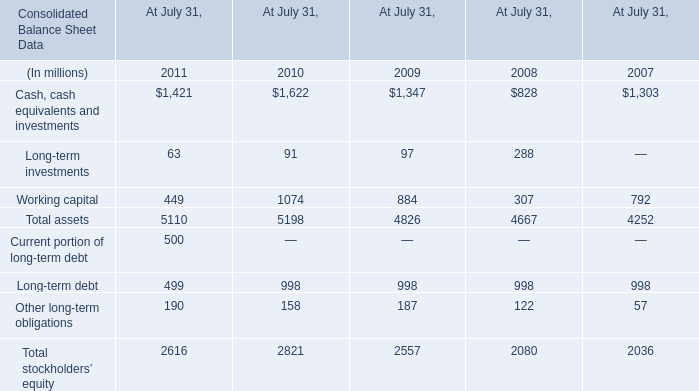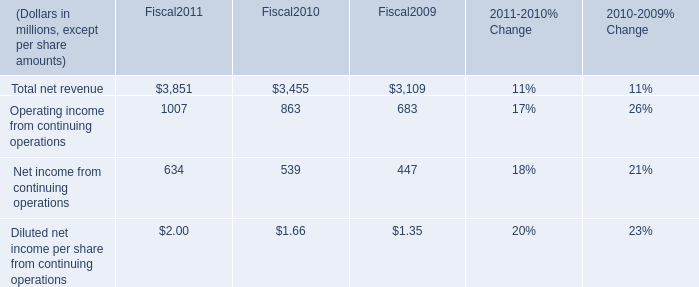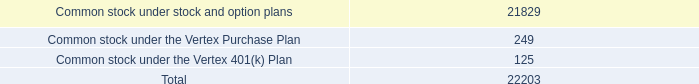What is the total amount of Cash, cash equivalents and investments of At July 31, 2011, and Operating income from continuing operations of Fiscal2011 ? 
Computations: (1421.0 + 1007.0)
Answer: 2428.0. 